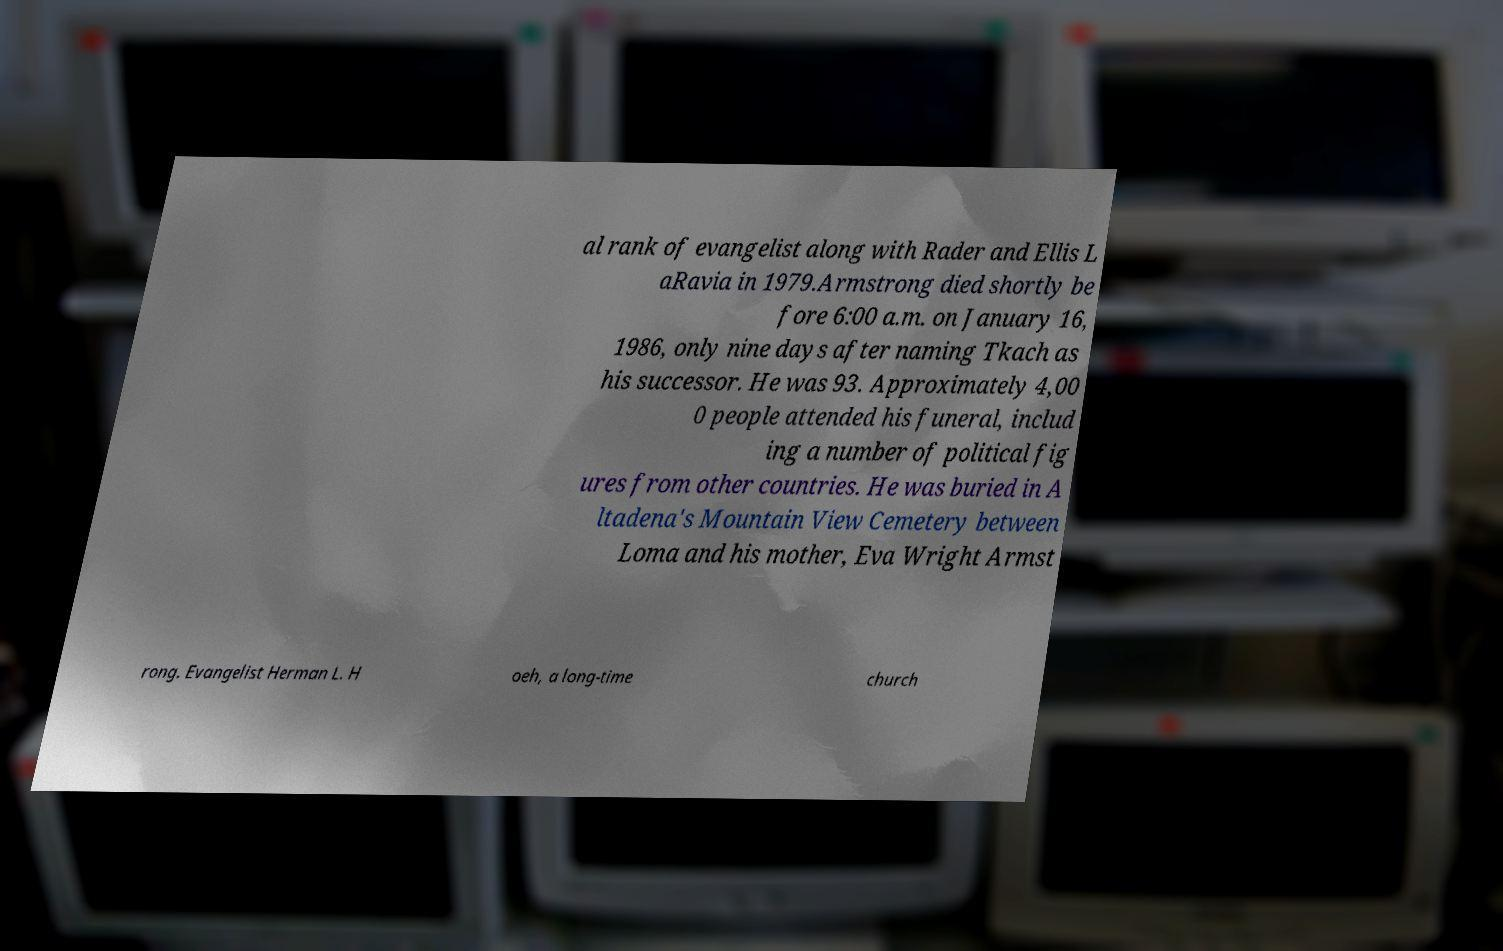Could you assist in decoding the text presented in this image and type it out clearly? al rank of evangelist along with Rader and Ellis L aRavia in 1979.Armstrong died shortly be fore 6:00 a.m. on January 16, 1986, only nine days after naming Tkach as his successor. He was 93. Approximately 4,00 0 people attended his funeral, includ ing a number of political fig ures from other countries. He was buried in A ltadena's Mountain View Cemetery between Loma and his mother, Eva Wright Armst rong. Evangelist Herman L. H oeh, a long-time church 